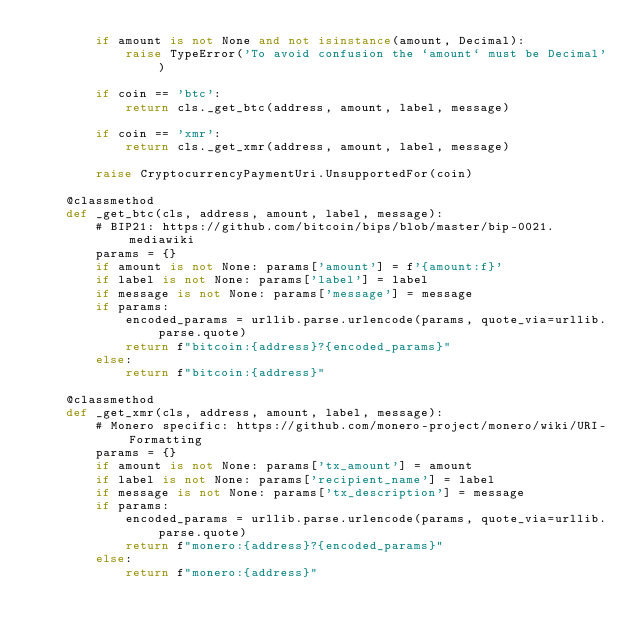Convert code to text. <code><loc_0><loc_0><loc_500><loc_500><_Python_>        if amount is not None and not isinstance(amount, Decimal):
            raise TypeError('To avoid confusion the `amount` must be Decimal')

        if coin == 'btc':
            return cls._get_btc(address, amount, label, message)

        if coin == 'xmr':
            return cls._get_xmr(address, amount, label, message)

        raise CryptocurrencyPaymentUri.UnsupportedFor(coin)

    @classmethod
    def _get_btc(cls, address, amount, label, message):
        # BIP21: https://github.com/bitcoin/bips/blob/master/bip-0021.mediawiki
        params = {}
        if amount is not None: params['amount'] = f'{amount:f}'
        if label is not None: params['label'] = label
        if message is not None: params['message'] = message
        if params:
            encoded_params = urllib.parse.urlencode(params, quote_via=urllib.parse.quote)
            return f"bitcoin:{address}?{encoded_params}"
        else:
            return f"bitcoin:{address}"

    @classmethod
    def _get_xmr(cls, address, amount, label, message):
        # Monero specific: https://github.com/monero-project/monero/wiki/URI-Formatting
        params = {}
        if amount is not None: params['tx_amount'] = amount
        if label is not None: params['recipient_name'] = label
        if message is not None: params['tx_description'] = message
        if params:
            encoded_params = urllib.parse.urlencode(params, quote_via=urllib.parse.quote)
            return f"monero:{address}?{encoded_params}"
        else:
            return f"monero:{address}"
</code> 